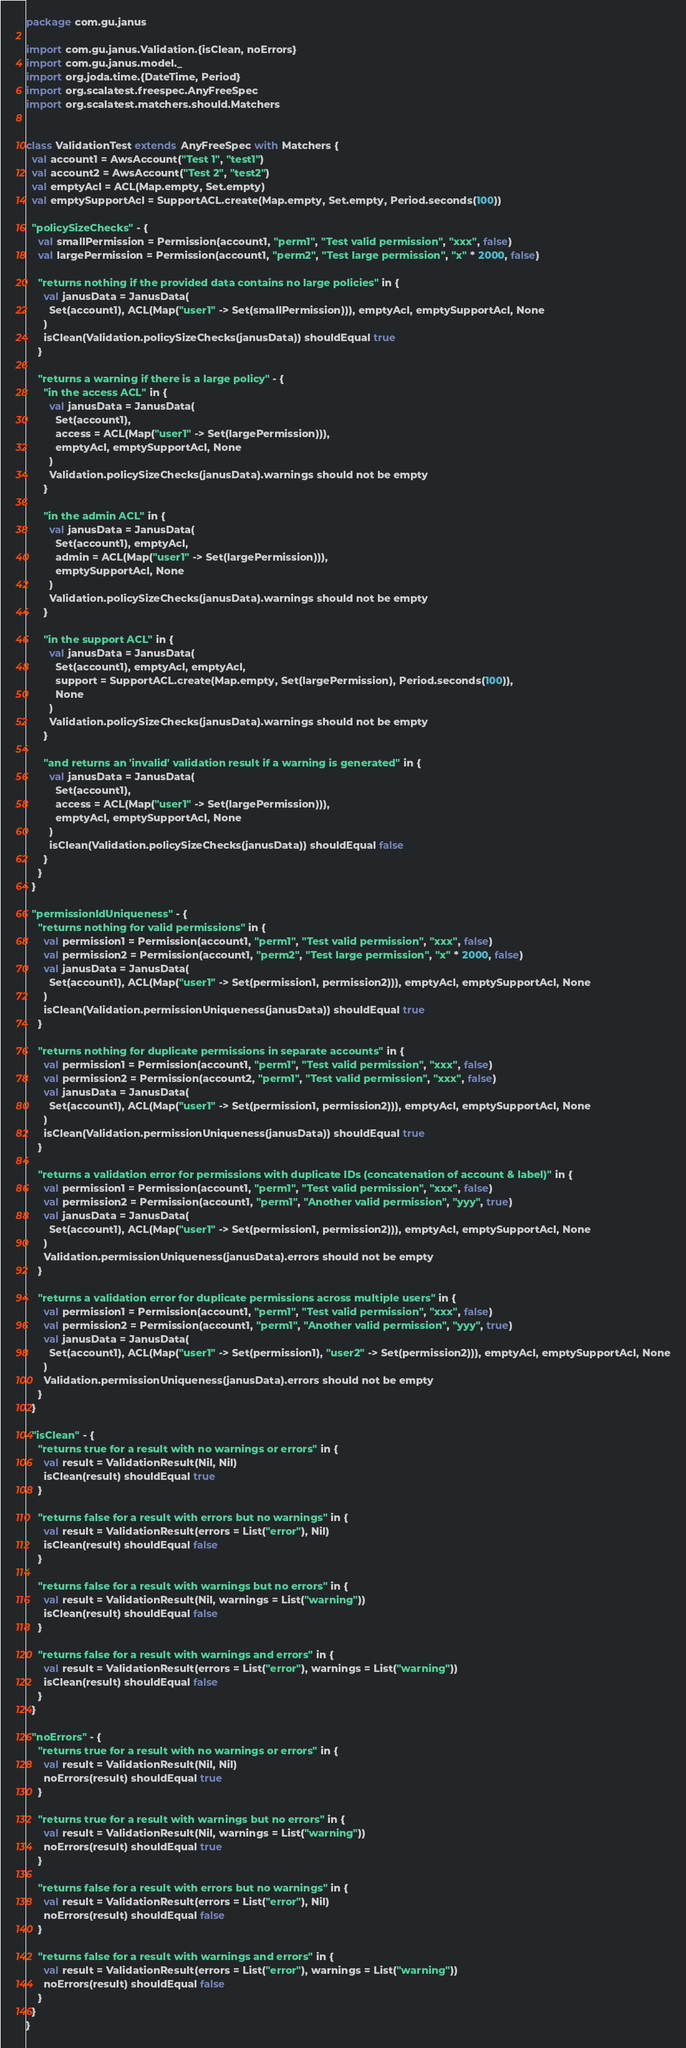<code> <loc_0><loc_0><loc_500><loc_500><_Scala_>package com.gu.janus

import com.gu.janus.Validation.{isClean, noErrors}
import com.gu.janus.model._
import org.joda.time.{DateTime, Period}
import org.scalatest.freespec.AnyFreeSpec
import org.scalatest.matchers.should.Matchers


class ValidationTest extends AnyFreeSpec with Matchers {
  val account1 = AwsAccount("Test 1", "test1")
  val account2 = AwsAccount("Test 2", "test2")
  val emptyAcl = ACL(Map.empty, Set.empty)
  val emptySupportAcl = SupportACL.create(Map.empty, Set.empty, Period.seconds(100))

  "policySizeChecks" - {
    val smallPermission = Permission(account1, "perm1", "Test valid permission", "xxx", false)
    val largePermission = Permission(account1, "perm2", "Test large permission", "x" * 2000, false)

    "returns nothing if the provided data contains no large policies" in {
      val janusData = JanusData(
        Set(account1), ACL(Map("user1" -> Set(smallPermission))), emptyAcl, emptySupportAcl, None
      )
      isClean(Validation.policySizeChecks(janusData)) shouldEqual true
    }

    "returns a warning if there is a large policy" - {
      "in the access ACL" in {
        val janusData = JanusData(
          Set(account1),
          access = ACL(Map("user1" -> Set(largePermission))),
          emptyAcl, emptySupportAcl, None
        )
        Validation.policySizeChecks(janusData).warnings should not be empty
      }

      "in the admin ACL" in {
        val janusData = JanusData(
          Set(account1), emptyAcl,
          admin = ACL(Map("user1" -> Set(largePermission))),
          emptySupportAcl, None
        )
        Validation.policySizeChecks(janusData).warnings should not be empty
      }

      "in the support ACL" in {
        val janusData = JanusData(
          Set(account1), emptyAcl, emptyAcl,
          support = SupportACL.create(Map.empty, Set(largePermission), Period.seconds(100)),
          None
        )
        Validation.policySizeChecks(janusData).warnings should not be empty
      }

      "and returns an 'invalid' validation result if a warning is generated" in {
        val janusData = JanusData(
          Set(account1),
          access = ACL(Map("user1" -> Set(largePermission))),
          emptyAcl, emptySupportAcl, None
        )
        isClean(Validation.policySizeChecks(janusData)) shouldEqual false
      }
    }
  }

  "permissionIdUniqueness" - {
    "returns nothing for valid permissions" in {
      val permission1 = Permission(account1, "perm1", "Test valid permission", "xxx", false)
      val permission2 = Permission(account1, "perm2", "Test large permission", "x" * 2000, false)
      val janusData = JanusData(
        Set(account1), ACL(Map("user1" -> Set(permission1, permission2))), emptyAcl, emptySupportAcl, None
      )
      isClean(Validation.permissionUniqueness(janusData)) shouldEqual true
    }

    "returns nothing for duplicate permissions in separate accounts" in {
      val permission1 = Permission(account1, "perm1", "Test valid permission", "xxx", false)
      val permission2 = Permission(account2, "perm1", "Test valid permission", "xxx", false)
      val janusData = JanusData(
        Set(account1), ACL(Map("user1" -> Set(permission1, permission2))), emptyAcl, emptySupportAcl, None
      )
      isClean(Validation.permissionUniqueness(janusData)) shouldEqual true
    }

    "returns a validation error for permissions with duplicate IDs (concatenation of account & label)" in {
      val permission1 = Permission(account1, "perm1", "Test valid permission", "xxx", false)
      val permission2 = Permission(account1, "perm1", "Another valid permission", "yyy", true)
      val janusData = JanusData(
        Set(account1), ACL(Map("user1" -> Set(permission1, permission2))), emptyAcl, emptySupportAcl, None
      )
      Validation.permissionUniqueness(janusData).errors should not be empty
    }

    "returns a validation error for duplicate permissions across multiple users" in {
      val permission1 = Permission(account1, "perm1", "Test valid permission", "xxx", false)
      val permission2 = Permission(account1, "perm1", "Another valid permission", "yyy", true)
      val janusData = JanusData(
        Set(account1), ACL(Map("user1" -> Set(permission1), "user2" -> Set(permission2))), emptyAcl, emptySupportAcl, None
      )
      Validation.permissionUniqueness(janusData).errors should not be empty
    }
  }

  "isClean" - {
    "returns true for a result with no warnings or errors" in {
      val result = ValidationResult(Nil, Nil)
      isClean(result) shouldEqual true
    }

    "returns false for a result with errors but no warnings" in {
      val result = ValidationResult(errors = List("error"), Nil)
      isClean(result) shouldEqual false
    }

    "returns false for a result with warnings but no errors" in {
      val result = ValidationResult(Nil, warnings = List("warning"))
      isClean(result) shouldEqual false
    }

    "returns false for a result with warnings and errors" in {
      val result = ValidationResult(errors = List("error"), warnings = List("warning"))
      isClean(result) shouldEqual false
    }
  }

  "noErrors" - {
    "returns true for a result with no warnings or errors" in {
      val result = ValidationResult(Nil, Nil)
      noErrors(result) shouldEqual true
    }

    "returns true for a result with warnings but no errors" in {
      val result = ValidationResult(Nil, warnings = List("warning"))
      noErrors(result) shouldEqual true
    }

    "returns false for a result with errors but no warnings" in {
      val result = ValidationResult(errors = List("error"), Nil)
      noErrors(result) shouldEqual false
    }

    "returns false for a result with warnings and errors" in {
      val result = ValidationResult(errors = List("error"), warnings = List("warning"))
      noErrors(result) shouldEqual false
    }
  }
}
</code> 